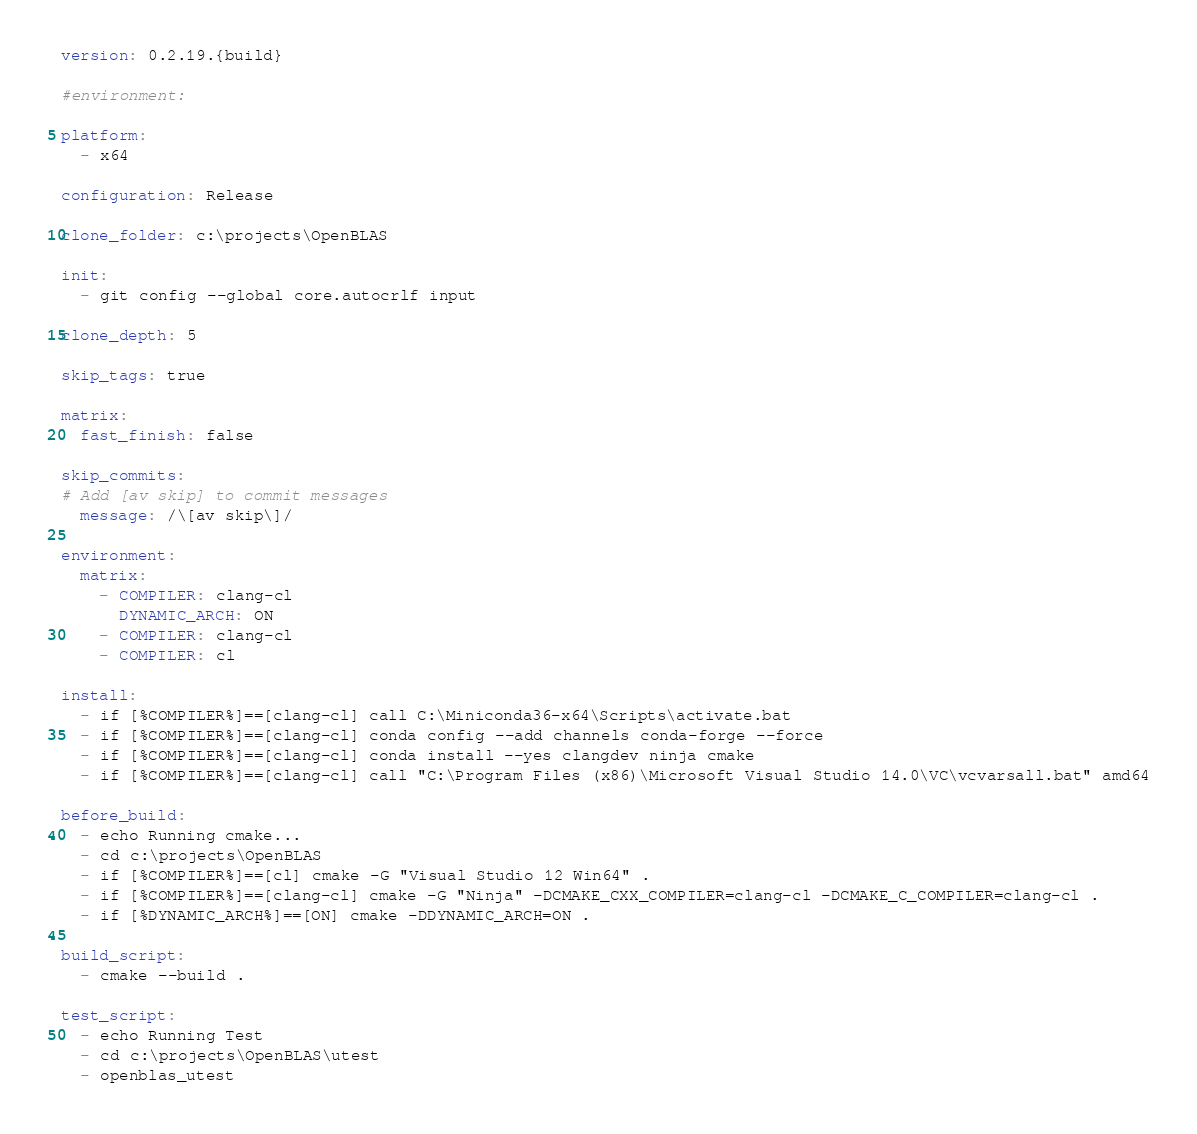<code> <loc_0><loc_0><loc_500><loc_500><_YAML_>version: 0.2.19.{build}

#environment:

platform: 
  - x64

configuration: Release

clone_folder: c:\projects\OpenBLAS

init:
  - git config --global core.autocrlf input

clone_depth: 5

skip_tags: true

matrix:
  fast_finish: false

skip_commits:
# Add [av skip] to commit messages
  message: /\[av skip\]/

environment:
  matrix:
    - COMPILER: clang-cl
      DYNAMIC_ARCH: ON
    - COMPILER: clang-cl
    - COMPILER: cl

install:
  - if [%COMPILER%]==[clang-cl] call C:\Miniconda36-x64\Scripts\activate.bat
  - if [%COMPILER%]==[clang-cl] conda config --add channels conda-forge --force
  - if [%COMPILER%]==[clang-cl] conda install --yes clangdev ninja cmake
  - if [%COMPILER%]==[clang-cl] call "C:\Program Files (x86)\Microsoft Visual Studio 14.0\VC\vcvarsall.bat" amd64

before_build:
  - echo Running cmake...
  - cd c:\projects\OpenBLAS
  - if [%COMPILER%]==[cl] cmake -G "Visual Studio 12 Win64" .
  - if [%COMPILER%]==[clang-cl] cmake -G "Ninja" -DCMAKE_CXX_COMPILER=clang-cl -DCMAKE_C_COMPILER=clang-cl .
  - if [%DYNAMIC_ARCH%]==[ON] cmake -DDYNAMIC_ARCH=ON .

build_script:
  - cmake --build .

test_script:
  - echo Running Test
  - cd c:\projects\OpenBLAS\utest
  - openblas_utest
</code> 